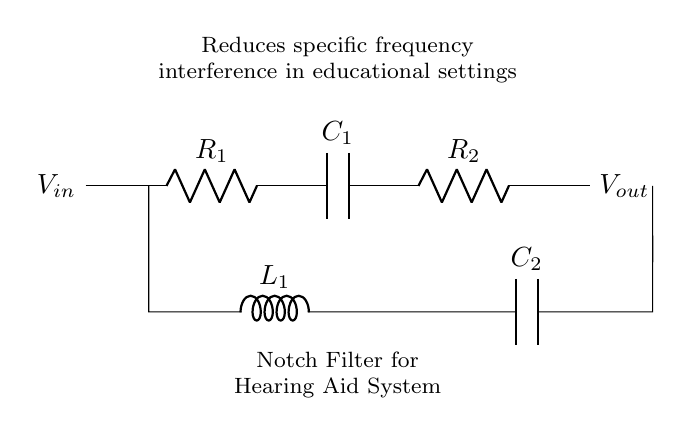What type of filter is depicted in the circuit? The circuit diagram specifically shows a notch filter, which is designed to eliminate a narrow band of frequencies. This is clear from the labeling in the diagram that identifies it as a notch filter for interference reduction.
Answer: Notch filter What components are used in this filter circuit? The circuit includes resistors (R1, R2), capacitors (C1, C2), and an inductor (L1). These components are labeled in the diagram, indicating their specific roles in the filtering process.
Answer: Resistors, capacitors, inductor What is the purpose of this notch filter in hearing aids? The purpose is to reduce specific frequency interference, which can help users focus on desired sounds, such as speech, in educational settings. The diagram includes a note explaining its intended application.
Answer: Reduce frequency interference How many resistors are present in the circuit? There are two resistors indicated in the circuit diagram: R1 and R2. The count can be easily seen by visually scanning the labeled components within the circuit.
Answer: Two What is the effect of the inductor in the filter circuit? The inductor (L1) serves to block high-frequency signals while allowing lower frequencies to pass. This property helps in shaping the filter's response, particularly for frequencies around the notch.
Answer: Block high frequencies What does the notation "V_in" and "V_out" signify in this circuit? "V_in" refers to the input voltage applied to the circuit, while "V_out" indicates the output voltage after the filtering process has occurred. The notations clearly show the points where the voltage is measured.
Answer: Input and output voltages 